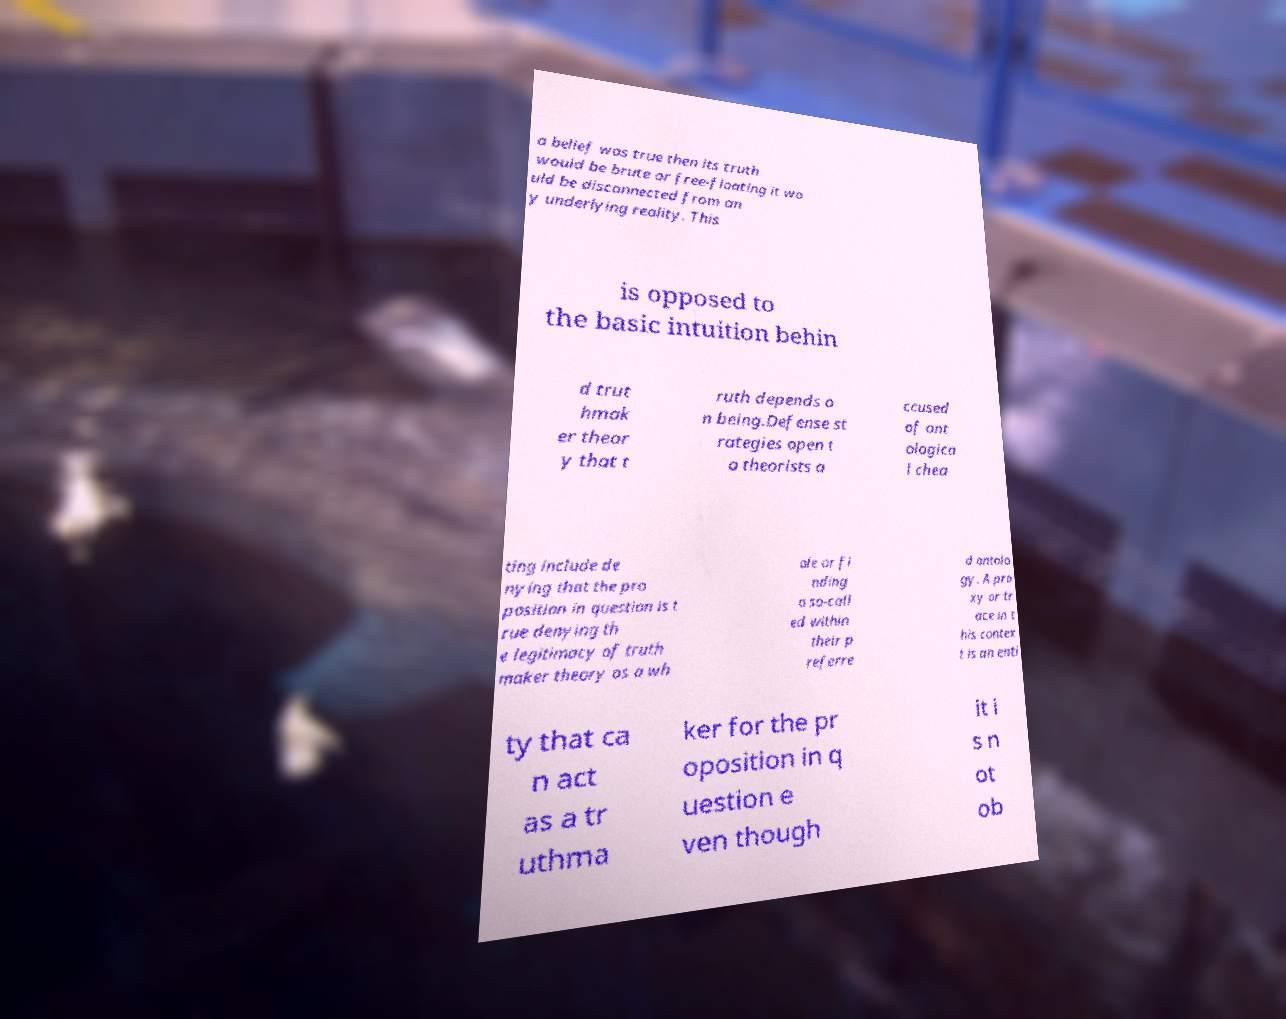Could you extract and type out the text from this image? a belief was true then its truth would be brute or free-floating it wo uld be disconnected from an y underlying reality. This is opposed to the basic intuition behin d trut hmak er theor y that t ruth depends o n being.Defense st rategies open t o theorists a ccused of ont ologica l chea ting include de nying that the pro position in question is t rue denying th e legitimacy of truth maker theory as a wh ole or fi nding a so-call ed within their p referre d ontolo gy. A pro xy or tr ace in t his contex t is an enti ty that ca n act as a tr uthma ker for the pr oposition in q uestion e ven though it i s n ot ob 